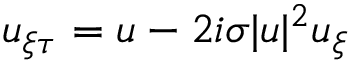Convert formula to latex. <formula><loc_0><loc_0><loc_500><loc_500>\begin{array} { r } { u _ { \xi \tau } = u - 2 i \sigma | u | ^ { 2 } u _ { \xi } } \end{array}</formula> 